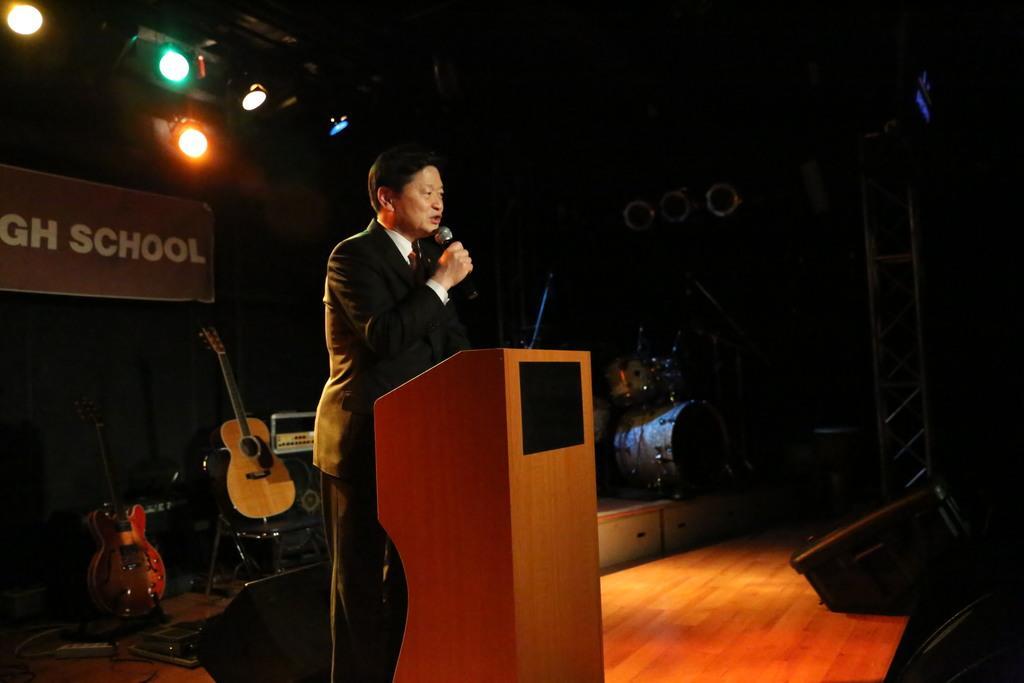Can you describe this image briefly? Man standing near the podium,here there are musical instruments ,this is chair and the poster and the light. 